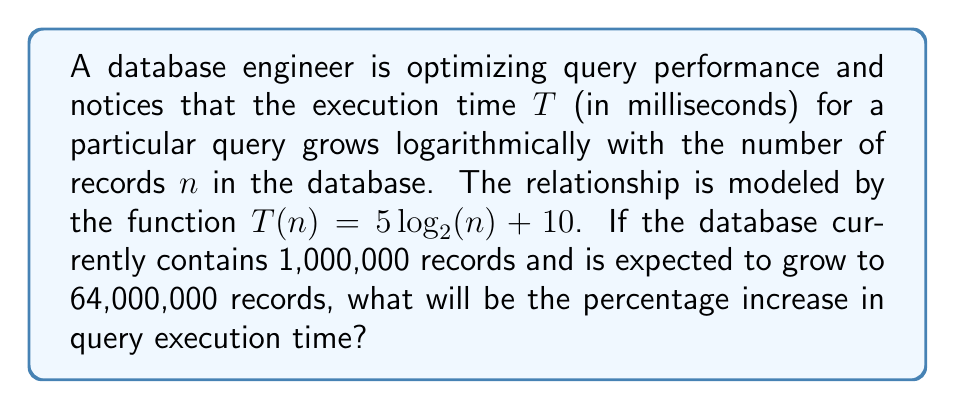Teach me how to tackle this problem. Let's approach this step-by-step:

1) First, we need to calculate the current execution time for 1,000,000 records:
   $T(1,000,000) = 5 \log_2(1,000,000) + 10$
   $= 5 \cdot 20 + 10$ (since $2^{20} = 1,048,576 \approx 1,000,000$)
   $= 100 + 10 = 110$ ms

2) Next, let's calculate the execution time for 64,000,000 records:
   $T(64,000,000) = 5 \log_2(64,000,000) + 10$
   $= 5 \cdot 26 + 10$ (since $2^{26} = 67,108,864 \approx 64,000,000$)
   $= 130 + 10 = 140$ ms

3) Now, we can calculate the increase in execution time:
   Increase = $140 - 110 = 30$ ms

4) To find the percentage increase, we use the formula:
   Percentage increase = $\frac{\text{Increase}}{\text{Original}} \times 100\%$
   $= \frac{30}{110} \times 100\% \approx 27.27\%$
Answer: 27.27% 